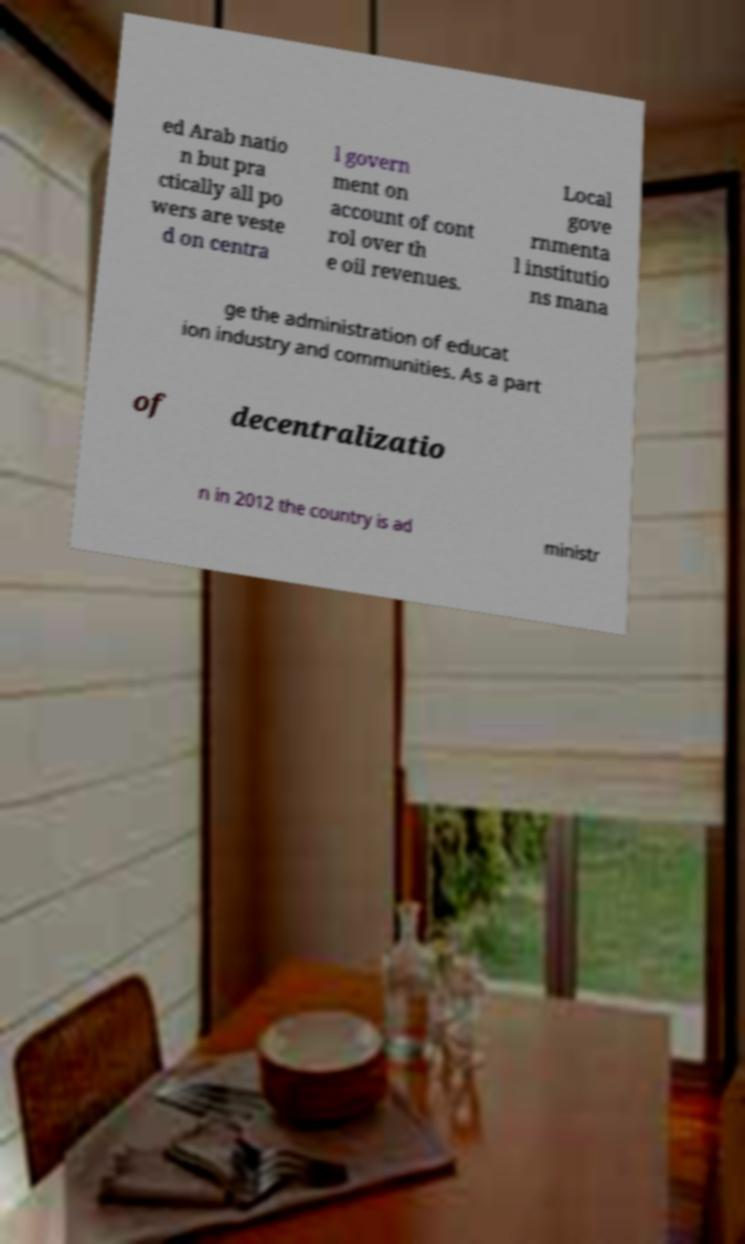Please identify and transcribe the text found in this image. ed Arab natio n but pra ctically all po wers are veste d on centra l govern ment on account of cont rol over th e oil revenues. Local gove rnmenta l institutio ns mana ge the administration of educat ion industry and communities. As a part of decentralizatio n in 2012 the country is ad ministr 